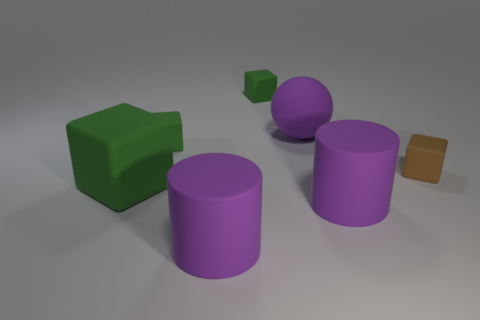How many other tiny matte objects are the same shape as the tiny brown matte thing?
Your response must be concise. 2. How many green things are either tiny cubes or large cylinders?
Give a very brief answer. 2. What is the size of the purple object to the left of the large purple rubber thing that is behind the brown matte thing?
Offer a very short reply. Large. What number of rubber blocks are the same size as the rubber sphere?
Provide a succinct answer. 1. Is the size of the sphere the same as the brown matte block?
Give a very brief answer. No. There is a matte object that is both behind the brown matte block and in front of the big purple sphere; what size is it?
Make the answer very short. Small. Is the number of brown things that are on the right side of the purple rubber sphere greater than the number of big purple matte things that are in front of the big green block?
Ensure brevity in your answer.  No. What is the color of the big object that is the same shape as the tiny brown object?
Your answer should be compact. Green. Do the large rubber object to the right of the purple ball and the sphere have the same color?
Give a very brief answer. Yes. What number of small yellow rubber spheres are there?
Keep it short and to the point. 0. 